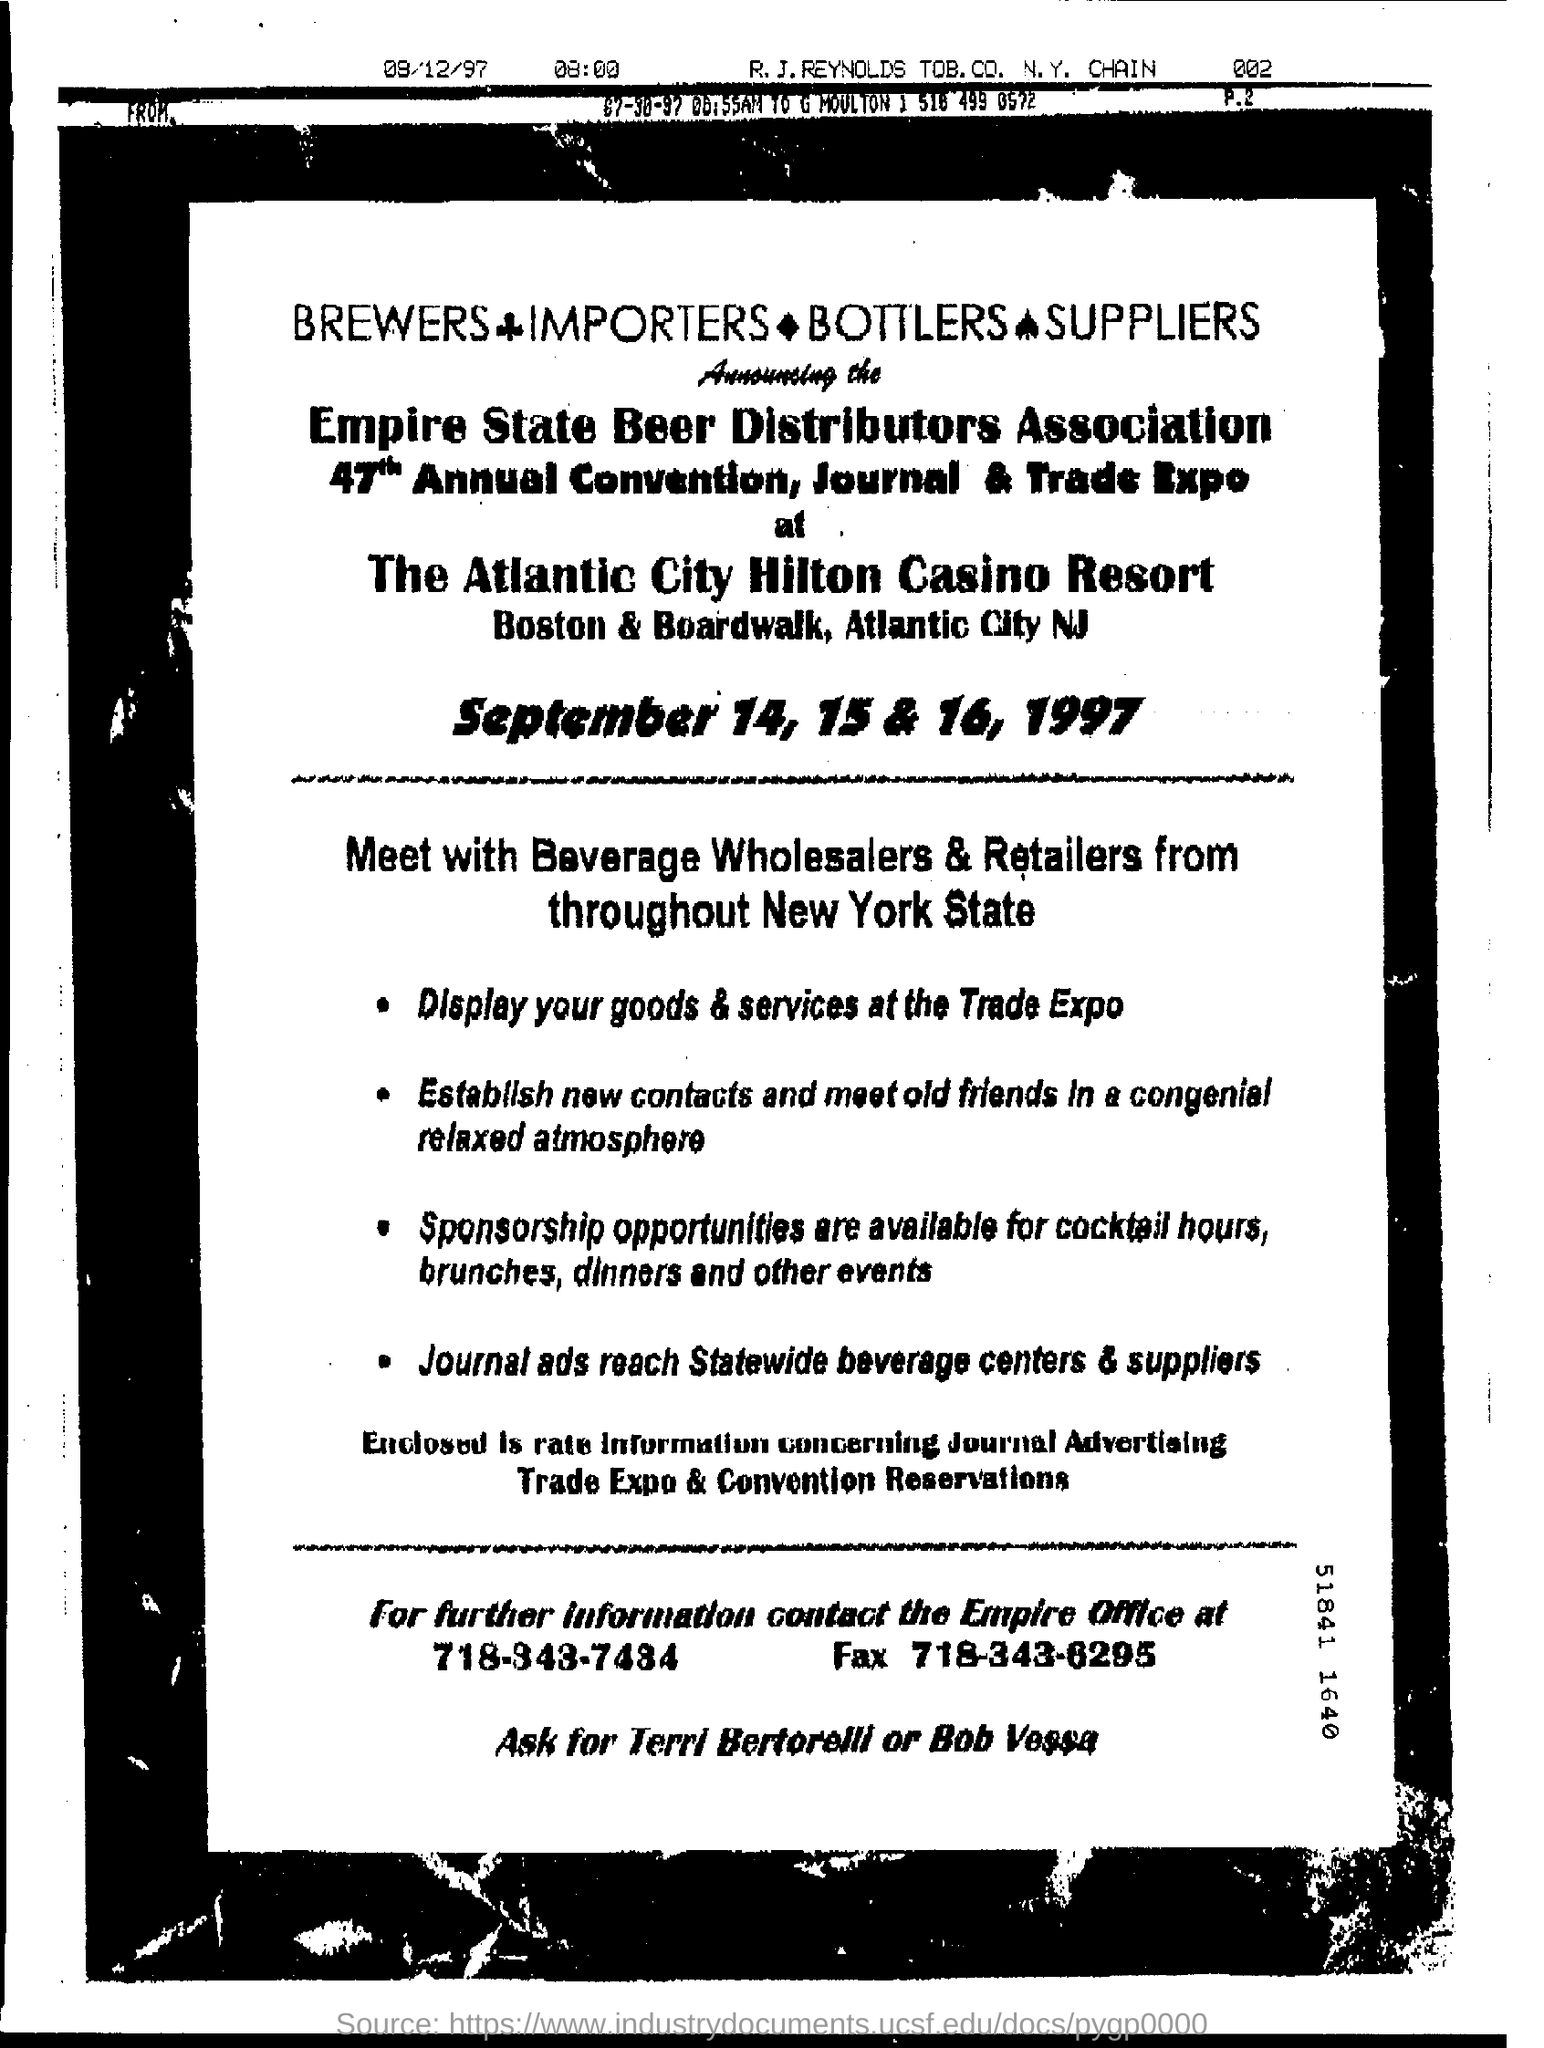When is the convention happening?
Give a very brief answer. September 14, 15 & 16, 1997. Who are to be contacted for further information?
Offer a terse response. Terri Bertorelli or Bob Vessa. When is this event?
Your answer should be very brief. September 14, 15 & 16 , 1997. 